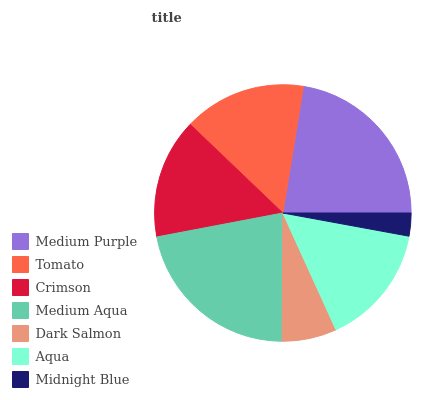Is Midnight Blue the minimum?
Answer yes or no. Yes. Is Medium Purple the maximum?
Answer yes or no. Yes. Is Tomato the minimum?
Answer yes or no. No. Is Tomato the maximum?
Answer yes or no. No. Is Medium Purple greater than Tomato?
Answer yes or no. Yes. Is Tomato less than Medium Purple?
Answer yes or no. Yes. Is Tomato greater than Medium Purple?
Answer yes or no. No. Is Medium Purple less than Tomato?
Answer yes or no. No. Is Aqua the high median?
Answer yes or no. Yes. Is Aqua the low median?
Answer yes or no. Yes. Is Medium Aqua the high median?
Answer yes or no. No. Is Dark Salmon the low median?
Answer yes or no. No. 